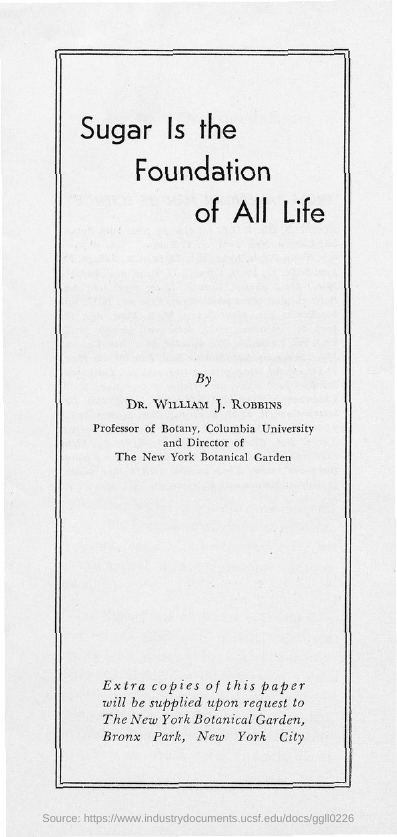Highlight a few significant elements in this photo. The title of the document is 'Sugar is the Foundation of All Life.' 